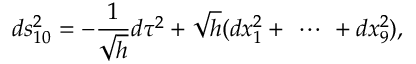Convert formula to latex. <formula><loc_0><loc_0><loc_500><loc_500>d s _ { 1 0 } ^ { 2 } = - \frac { 1 } { \sqrt { h } } d \tau ^ { 2 } + \sqrt { h } ( d x _ { 1 } ^ { 2 } + \ \cdots \ + d x _ { 9 } ^ { 2 } ) ,</formula> 